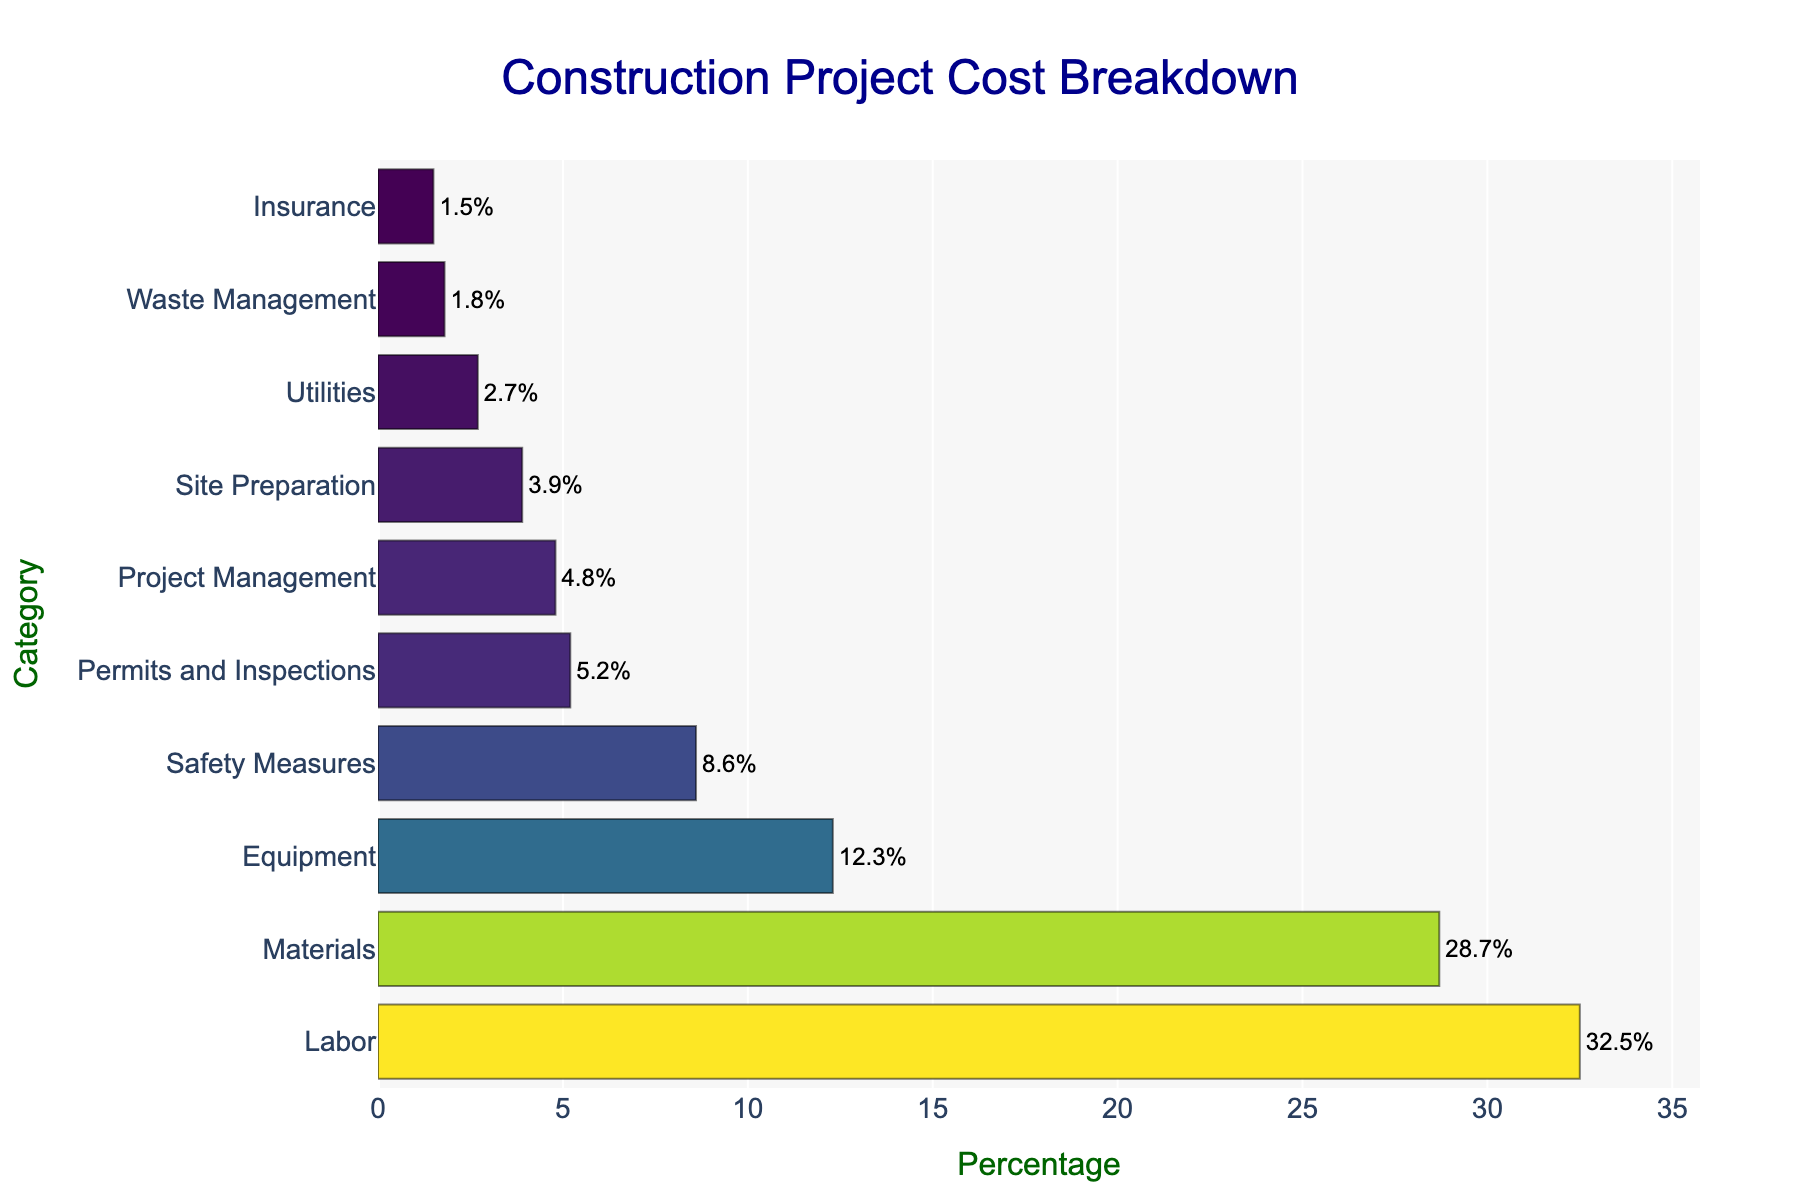What's the largest category by percentage in the construction project cost breakdown? The largest category can be identified by looking for the bar with the greatest length. In this case, it is the bar labeled "Labor." Its percentage is 32.5%.
Answer: Labor What's the difference in percentage between Labor and Materials costs? First, find the percentage values for Labor (32.5%) and Materials (28.7%). Then, subtract the Materials percentage from the Labor percentage: 32.5% - 28.7% = 3.8%.
Answer: 3.8% How do the costs for Safety Measures and Permits and Inspections compare in terms of percentage? Identify the percentages for Safety Measures (8.6%) and Permits and Inspections (5.2%), then observe that 8.6% is greater than 5.2%.
Answer: Safety Measures is greater Which category has the lowest percentage, and what is its value? The category with the shortest bar is "Insurance," and its percentage is 1.5%.
Answer: Insurance, 1.5% Are the combined costs for Project Management and Site Preparation greater than the costs for Equipment alone? Find the percentages for Project Management (4.8%) and Site Preparation (3.9%) and sum them up: 4.8% + 3.9% = 8.7%. Compare this value to the Equipment cost (12.3%). Since 8.7% is less than 12.3%, the combined costs are not greater.
Answer: No, they are not What percentage of the total cost do the three most significant categories (Labor, Materials, and Equipment) make up? Sum up the percentages of Labor (32.5%), Materials (28.7%), and Equipment (12.3%): 32.5% + 28.7% + 12.3% = 73.5%.
Answer: 73.5% How does the cost for Utilities compare relative to Site Preparation? Observe the percentages for Utilities (2.7%) and Site Preparation (3.9%). 2.7% is less than 3.9%.
Answer: Utilities is less What's the combined percentage of all categories that individually have less than 5% of the total cost? Sum the percentages of categories with less than 5%: Permits and Inspections (5.2%), Project Management (4.8%), Site Preparation (3.9%), Utilities (2.7%), Waste Management (1.8%), and Insurance (1.5%). Combined total is: 5.2% + 4.8% + 3.9% + 2.7% + 1.8% + 1.5% = 19.9%.
Answer: 19.9% Which three categories have the smallest cost percentages, and what are their values? Identify the three shortest bars: Insurance (1.5%), Waste Management (1.8%), and Utilities (2.7%).
Answer: Insurance (1.5%), Waste Management (1.8%), Utilities (2.7%) What's the overall visual trend you notice about the cost distribution among the categories? The visual trend shows that a few categories (Labor, Materials) constitute a significant portion of the total costs, while many smaller categories (like Insurance, Waste Management) together make up a much smaller portion.
Answer: Few large, many small 